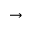Convert formula to latex. <formula><loc_0><loc_0><loc_500><loc_500>\rightarrow</formula> 